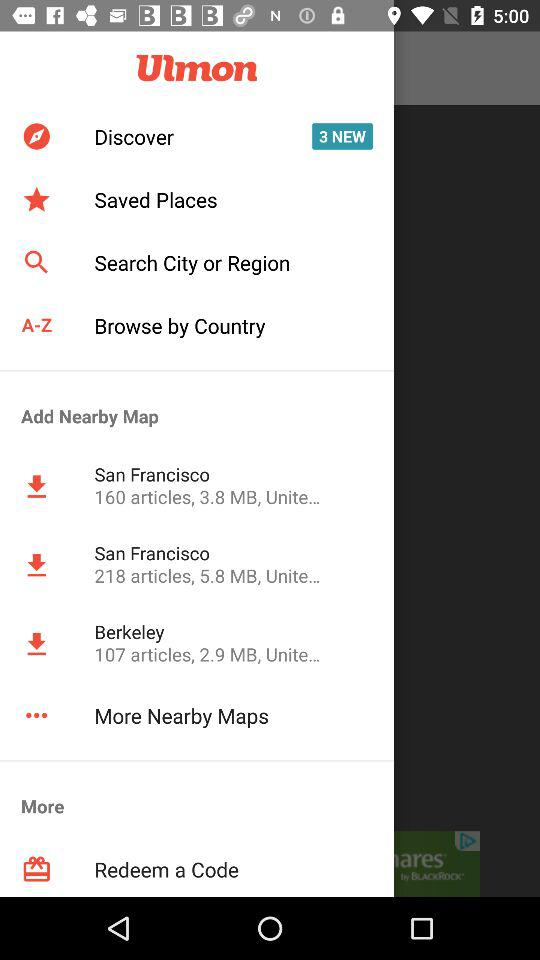How many more MB are there in the San Francisco map than the Berkeley map?
Answer the question using a single word or phrase. 2.9 